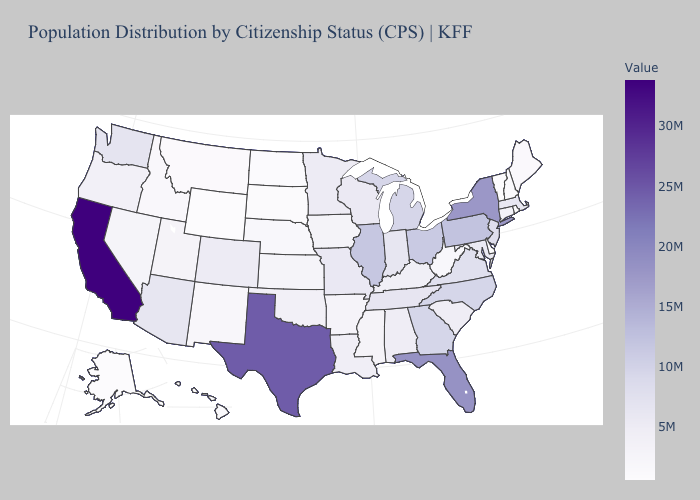Does the map have missing data?
Short answer required. No. Does Kentucky have the lowest value in the USA?
Answer briefly. No. Among the states that border Colorado , does Wyoming have the lowest value?
Give a very brief answer. Yes. Does Tennessee have a lower value than Delaware?
Quick response, please. No. 